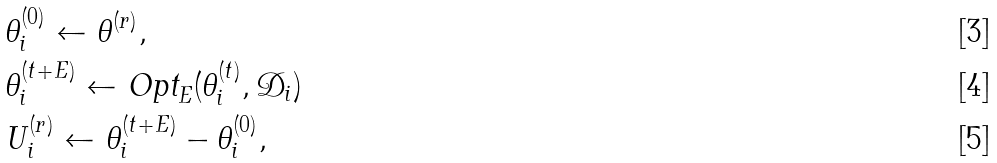Convert formula to latex. <formula><loc_0><loc_0><loc_500><loc_500>& \theta _ { i } ^ { ( 0 ) } \gets \theta ^ { ( r ) } , \\ & \theta _ { i } ^ { ( t + E ) } \gets \text {Opt} _ { E } ( \theta _ { i } ^ { ( t ) } , \mathcal { D } _ { i } ) \\ & U _ { i } ^ { ( r ) } \gets \theta _ { i } ^ { ( t + E ) } - \theta _ { i } ^ { ( 0 ) } ,</formula> 